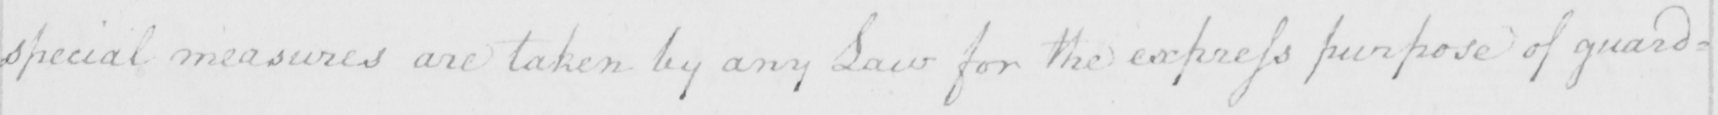Transcribe the text shown in this historical manuscript line. special measures are taken by any Law for the express purpose of guar= 